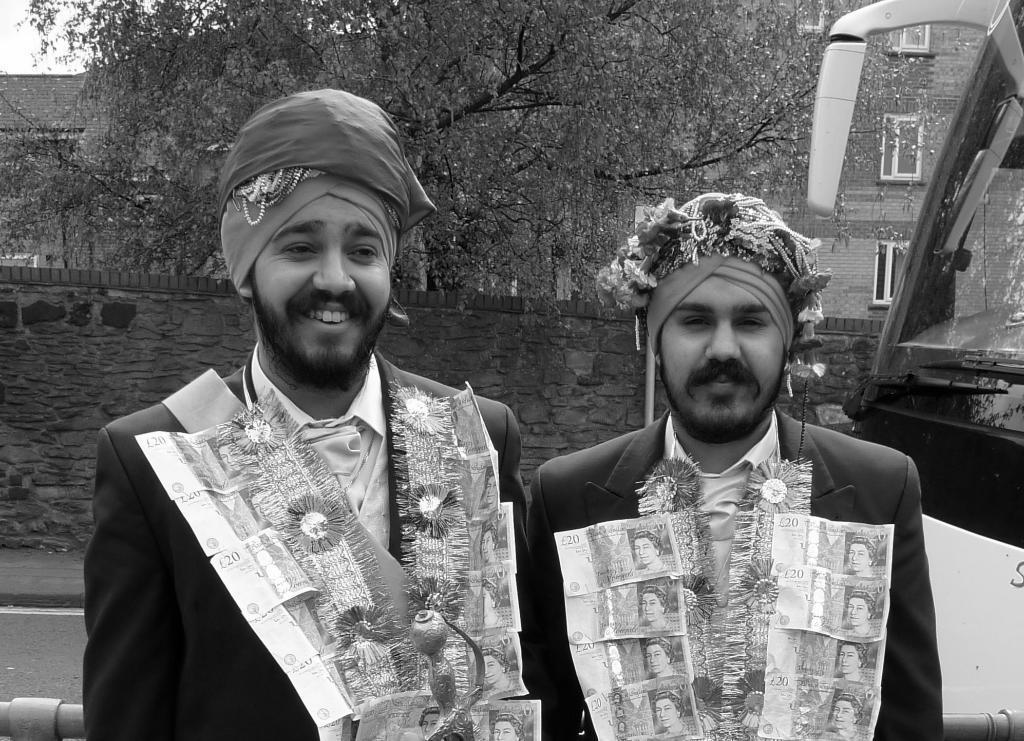How would you summarize this image in a sentence or two? In this picture we can see two men, the left side man is smiling, beside to them we can see a metal rod and a bus, in the background we can see a wall, few trees and buildings, and it is a black and white photography. 